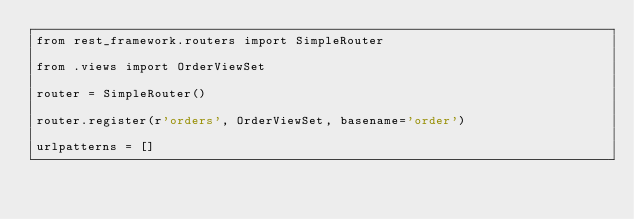Convert code to text. <code><loc_0><loc_0><loc_500><loc_500><_Python_>from rest_framework.routers import SimpleRouter

from .views import OrderViewSet

router = SimpleRouter()

router.register(r'orders', OrderViewSet, basename='order')

urlpatterns = []
</code> 